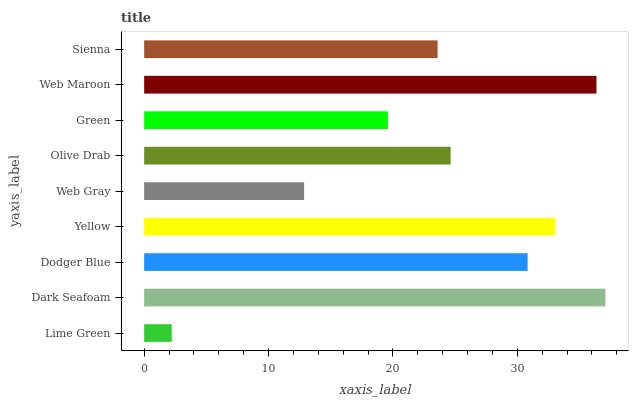Is Lime Green the minimum?
Answer yes or no. Yes. Is Dark Seafoam the maximum?
Answer yes or no. Yes. Is Dodger Blue the minimum?
Answer yes or no. No. Is Dodger Blue the maximum?
Answer yes or no. No. Is Dark Seafoam greater than Dodger Blue?
Answer yes or no. Yes. Is Dodger Blue less than Dark Seafoam?
Answer yes or no. Yes. Is Dodger Blue greater than Dark Seafoam?
Answer yes or no. No. Is Dark Seafoam less than Dodger Blue?
Answer yes or no. No. Is Olive Drab the high median?
Answer yes or no. Yes. Is Olive Drab the low median?
Answer yes or no. Yes. Is Yellow the high median?
Answer yes or no. No. Is Lime Green the low median?
Answer yes or no. No. 